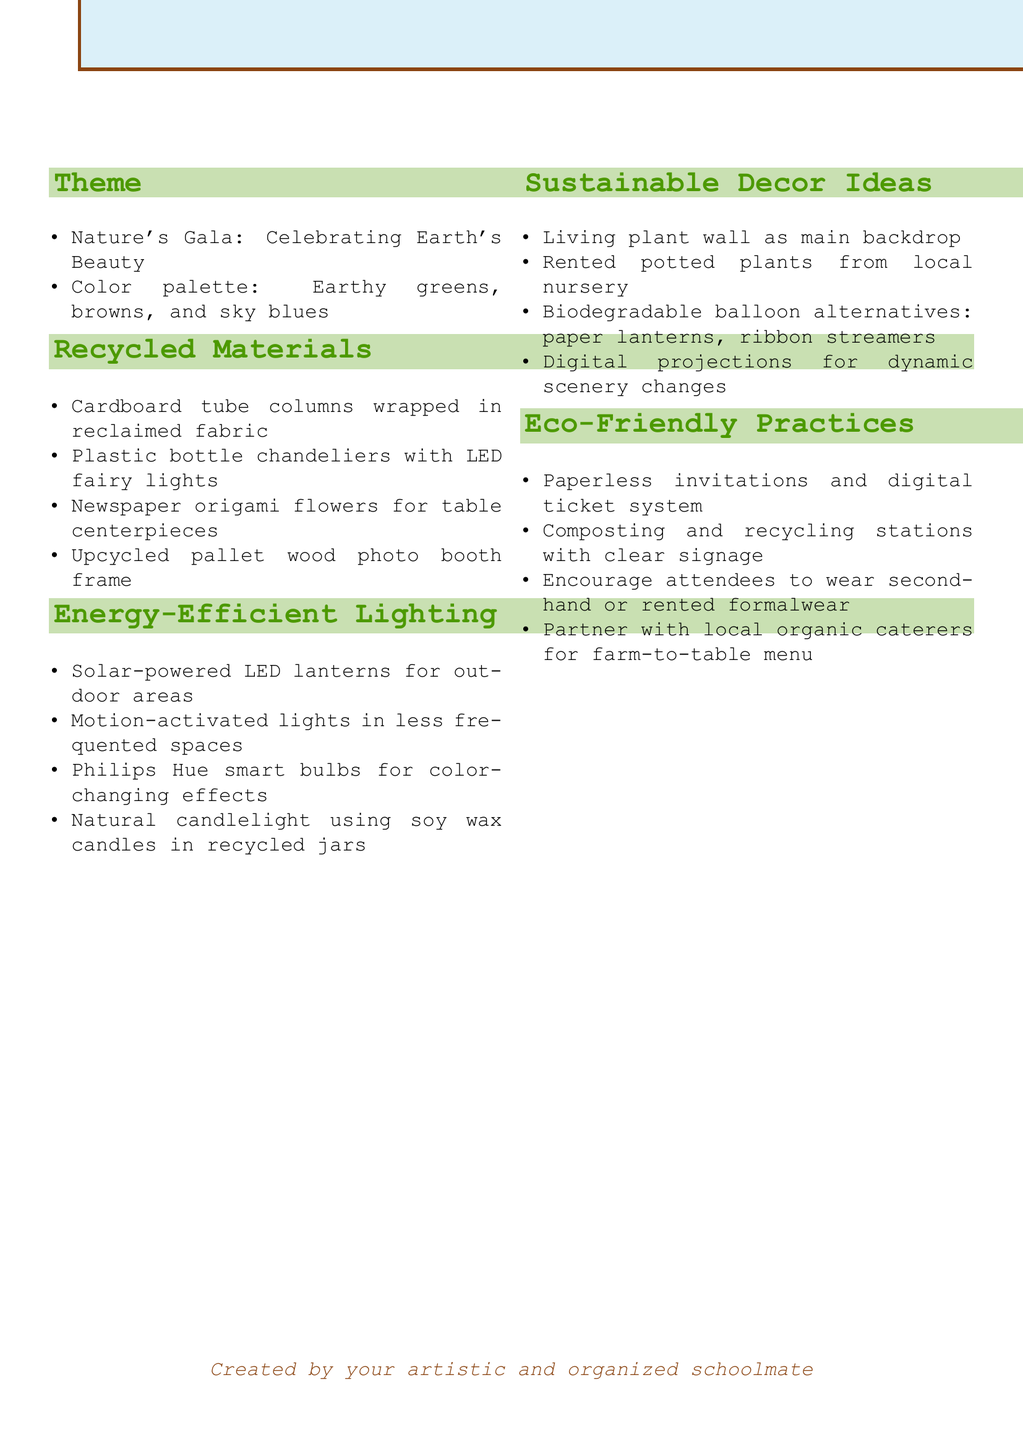What is the title of the document? The title is provided at the beginning of the document, stating the main theme and focus.
Answer: Eco-Friendly Prom: Sustainable Design Concepts How many sections are there in the document? The document is organized into multiple sections that cover various topics related to the prom theme.
Answer: 5 What color palette is suggested for the theme? The color palette is mentioned as part of the theme description.
Answer: Earthy greens, browns, and sky blues What type of centerpiece is suggested using recycled materials? The document lists specific items used for decoration, including centerpieces.
Answer: Newspaper origami flowers Which energy-efficient lighting option is mentioned for outdoor areas? The document highlights various lighting options to reduce energy consumption.
Answer: Solar-powered LED lanterns What is a suggested eco-friendly practice for invitations? The document offers alternative practices to traditional methods for inviting guests.
Answer: Paperless invitations and digital ticket system What main backdrop idea is proposed using sustainable decor? The document lists creative decor ideas that align with the eco-friendly theme.
Answer: Living plant wall What is recommended for photo booth frames? This document includes ideas for creating unique photo booth setups using eco-friendly materials.
Answer: Upcycled pallet wood photo booth frame How should attendees be encouraged to dress for the prom? The document provides suggestions for sustainable attire options for attendees.
Answer: Secondhand or rented formalwear 